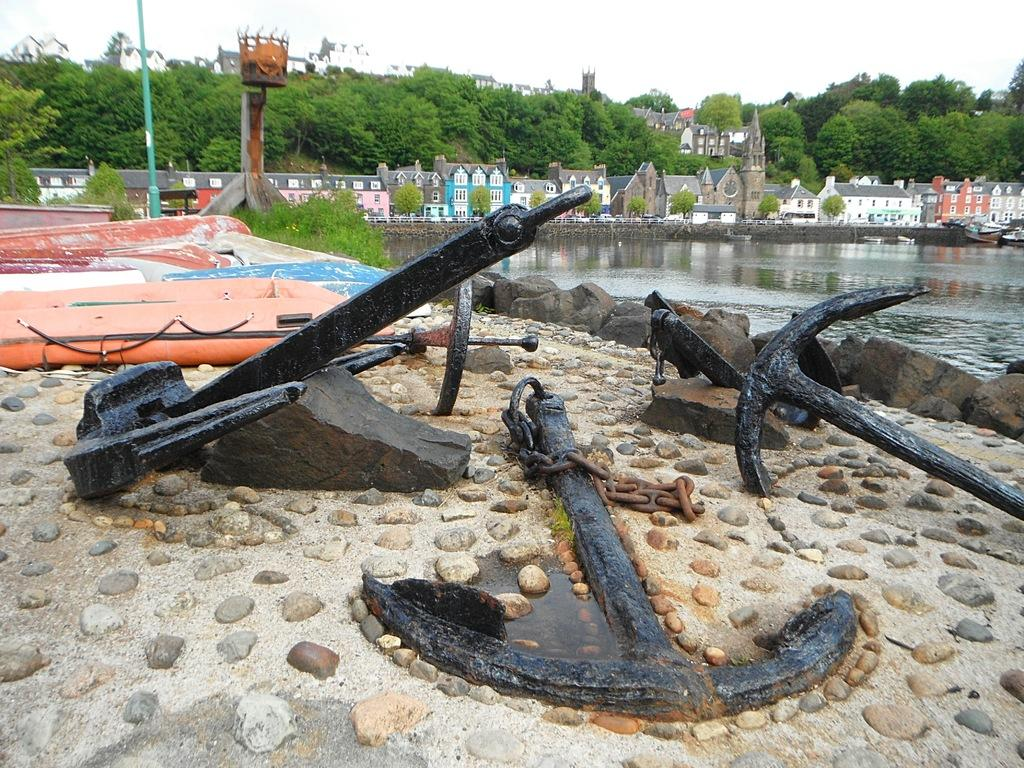What color are the anchors in the image? The anchors in the image are black. What type of objects can be seen in the image besides the anchors? There are stones, a lake, trees, plants, buildings, and the sky visible in the image. Where is the lake located in the image? The lake is on the right side of the image. What can be seen in the background of the image? In the background of the image, there are trees, plants, buildings, and the sky. Can you see a swing in the image? No, there is no swing present in the image. What type of cast is visible on the anchors in the image? There is no cast on the anchors in the image; they are simply black in color. 